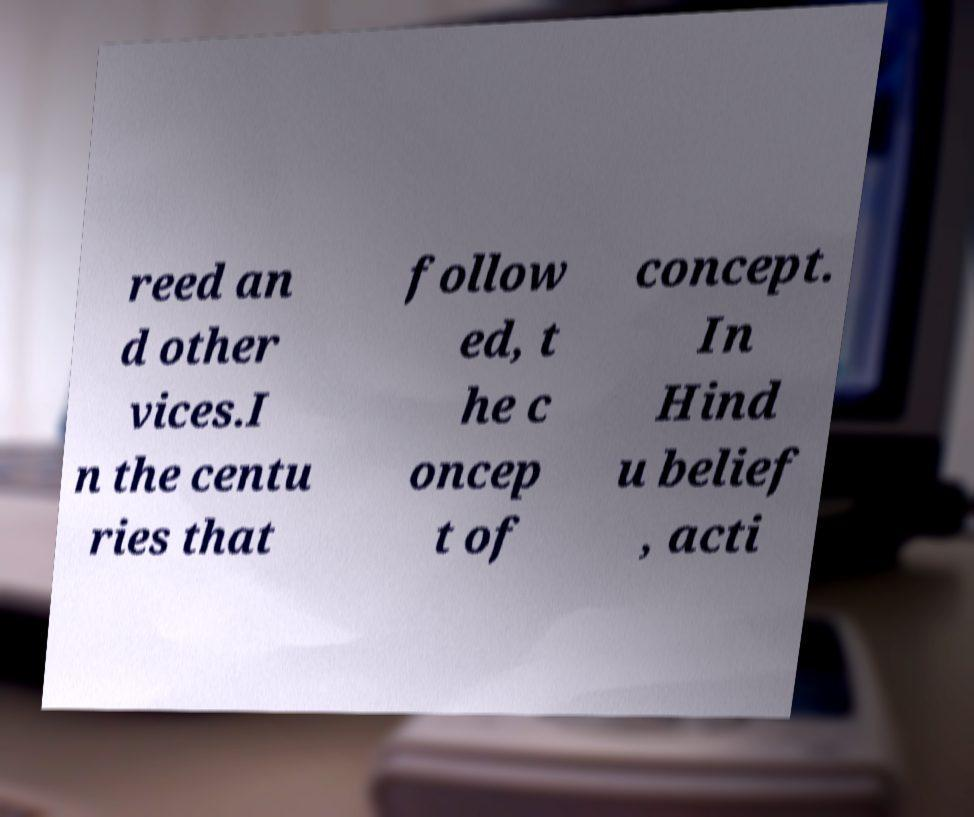Could you assist in decoding the text presented in this image and type it out clearly? reed an d other vices.I n the centu ries that follow ed, t he c oncep t of concept. In Hind u belief , acti 